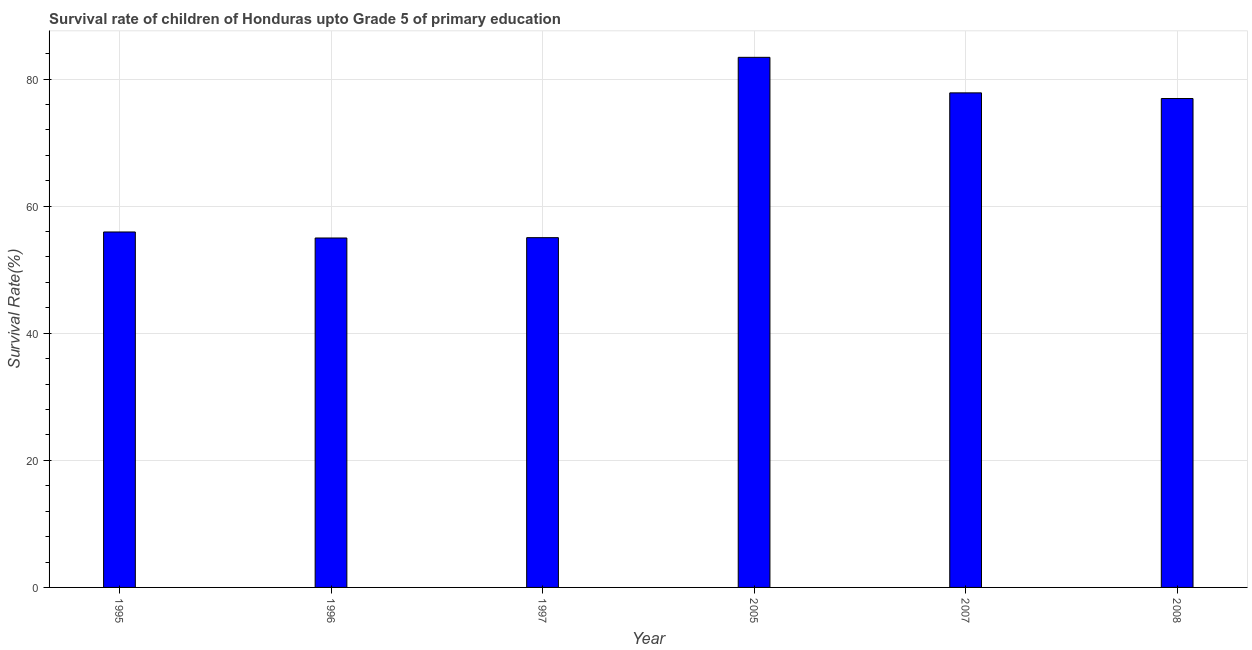Does the graph contain grids?
Your answer should be compact. Yes. What is the title of the graph?
Keep it short and to the point. Survival rate of children of Honduras upto Grade 5 of primary education. What is the label or title of the X-axis?
Ensure brevity in your answer.  Year. What is the label or title of the Y-axis?
Your answer should be compact. Survival Rate(%). What is the survival rate in 1996?
Provide a succinct answer. 54.99. Across all years, what is the maximum survival rate?
Give a very brief answer. 83.42. Across all years, what is the minimum survival rate?
Make the answer very short. 54.99. What is the sum of the survival rate?
Your answer should be very brief. 404.14. What is the difference between the survival rate in 1996 and 2005?
Your answer should be very brief. -28.43. What is the average survival rate per year?
Provide a short and direct response. 67.36. What is the median survival rate?
Your answer should be compact. 66.44. What is the ratio of the survival rate in 2007 to that in 2008?
Give a very brief answer. 1.01. Is the survival rate in 1996 less than that in 2005?
Your answer should be very brief. Yes. What is the difference between the highest and the second highest survival rate?
Give a very brief answer. 5.59. Is the sum of the survival rate in 1995 and 1997 greater than the maximum survival rate across all years?
Provide a short and direct response. Yes. What is the difference between the highest and the lowest survival rate?
Provide a short and direct response. 28.43. How many bars are there?
Offer a very short reply. 6. How many years are there in the graph?
Your answer should be very brief. 6. What is the difference between two consecutive major ticks on the Y-axis?
Offer a terse response. 20. What is the Survival Rate(%) in 1995?
Ensure brevity in your answer.  55.93. What is the Survival Rate(%) in 1996?
Your response must be concise. 54.99. What is the Survival Rate(%) in 1997?
Your answer should be compact. 55.04. What is the Survival Rate(%) in 2005?
Your response must be concise. 83.42. What is the Survival Rate(%) in 2007?
Your answer should be very brief. 77.83. What is the Survival Rate(%) of 2008?
Offer a terse response. 76.94. What is the difference between the Survival Rate(%) in 1995 and 1996?
Provide a succinct answer. 0.95. What is the difference between the Survival Rate(%) in 1995 and 1997?
Ensure brevity in your answer.  0.89. What is the difference between the Survival Rate(%) in 1995 and 2005?
Offer a very short reply. -27.48. What is the difference between the Survival Rate(%) in 1995 and 2007?
Keep it short and to the point. -21.89. What is the difference between the Survival Rate(%) in 1995 and 2008?
Your answer should be very brief. -21. What is the difference between the Survival Rate(%) in 1996 and 1997?
Give a very brief answer. -0.05. What is the difference between the Survival Rate(%) in 1996 and 2005?
Keep it short and to the point. -28.43. What is the difference between the Survival Rate(%) in 1996 and 2007?
Provide a succinct answer. -22.84. What is the difference between the Survival Rate(%) in 1996 and 2008?
Offer a very short reply. -21.95. What is the difference between the Survival Rate(%) in 1997 and 2005?
Offer a terse response. -28.38. What is the difference between the Survival Rate(%) in 1997 and 2007?
Your answer should be compact. -22.78. What is the difference between the Survival Rate(%) in 1997 and 2008?
Provide a succinct answer. -21.89. What is the difference between the Survival Rate(%) in 2005 and 2007?
Offer a very short reply. 5.59. What is the difference between the Survival Rate(%) in 2005 and 2008?
Your response must be concise. 6.48. What is the difference between the Survival Rate(%) in 2007 and 2008?
Your response must be concise. 0.89. What is the ratio of the Survival Rate(%) in 1995 to that in 1996?
Keep it short and to the point. 1.02. What is the ratio of the Survival Rate(%) in 1995 to that in 2005?
Offer a terse response. 0.67. What is the ratio of the Survival Rate(%) in 1995 to that in 2007?
Provide a short and direct response. 0.72. What is the ratio of the Survival Rate(%) in 1995 to that in 2008?
Ensure brevity in your answer.  0.73. What is the ratio of the Survival Rate(%) in 1996 to that in 1997?
Provide a short and direct response. 1. What is the ratio of the Survival Rate(%) in 1996 to that in 2005?
Ensure brevity in your answer.  0.66. What is the ratio of the Survival Rate(%) in 1996 to that in 2007?
Make the answer very short. 0.71. What is the ratio of the Survival Rate(%) in 1996 to that in 2008?
Ensure brevity in your answer.  0.71. What is the ratio of the Survival Rate(%) in 1997 to that in 2005?
Make the answer very short. 0.66. What is the ratio of the Survival Rate(%) in 1997 to that in 2007?
Offer a very short reply. 0.71. What is the ratio of the Survival Rate(%) in 1997 to that in 2008?
Provide a succinct answer. 0.71. What is the ratio of the Survival Rate(%) in 2005 to that in 2007?
Provide a short and direct response. 1.07. What is the ratio of the Survival Rate(%) in 2005 to that in 2008?
Keep it short and to the point. 1.08. 